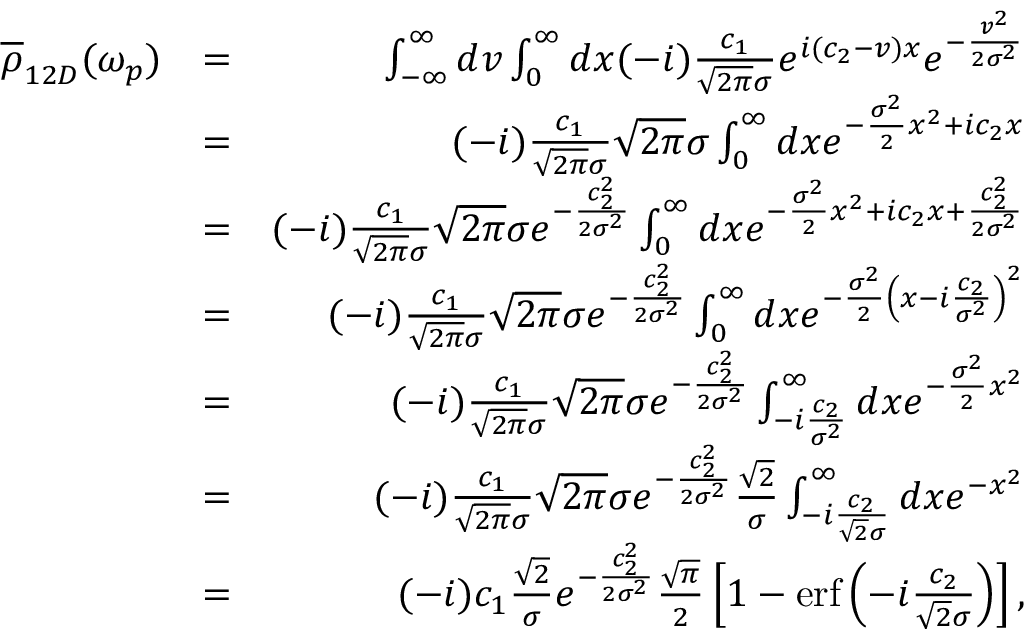Convert formula to latex. <formula><loc_0><loc_0><loc_500><loc_500>\begin{array} { r l r } { \overline { \rho } _ { 1 2 D } ( \omega _ { p } ) } & { = } & { \int _ { - \infty } ^ { \infty } d v \int _ { 0 } ^ { \infty } d x ( - i ) \frac { c _ { 1 } } { \sqrt { 2 \pi } \sigma } e ^ { i ( c _ { 2 } - v ) x } e ^ { - \frac { v ^ { 2 } } { 2 \sigma ^ { 2 } } } } \\ & { = } & { ( - i ) \frac { c _ { 1 } } { \sqrt { 2 \pi } \sigma } \sqrt { 2 \pi } \sigma \int _ { 0 } ^ { \infty } d x e ^ { - \frac { \sigma ^ { 2 } } { 2 } x ^ { 2 } + i c _ { 2 } x } } \\ & { = } & { ( - i ) \frac { c _ { 1 } } { \sqrt { 2 \pi } \sigma } \sqrt { 2 \pi } \sigma e ^ { - \frac { c _ { 2 } ^ { 2 } } { 2 \sigma ^ { 2 } } } \int _ { 0 } ^ { \infty } d x e ^ { - \frac { \sigma ^ { 2 } } { 2 } x ^ { 2 } + i c _ { 2 } x + \frac { c _ { 2 } ^ { 2 } } { 2 \sigma ^ { 2 } } } } \\ & { = } & { ( - i ) \frac { c _ { 1 } } { \sqrt { 2 \pi } \sigma } \sqrt { 2 \pi } \sigma e ^ { - \frac { c _ { 2 } ^ { 2 } } { 2 \sigma ^ { 2 } } } \int _ { 0 } ^ { \infty } d x e ^ { - \frac { \sigma ^ { 2 } } { 2 } \left ( x - i \frac { c _ { 2 } } { \sigma ^ { 2 } } \right ) ^ { 2 } } } \\ & { = } & { ( - i ) \frac { c _ { 1 } } { \sqrt { 2 \pi } \sigma } \sqrt { 2 \pi } \sigma e ^ { - \frac { c _ { 2 } ^ { 2 } } { 2 \sigma ^ { 2 } } } \int _ { - i \frac { c _ { 2 } } { \sigma ^ { 2 } } } ^ { \infty } d x e ^ { - \frac { \sigma ^ { 2 } } { 2 } x ^ { 2 } } } \\ & { = } & { ( - i ) \frac { c _ { 1 } } { \sqrt { 2 \pi } \sigma } \sqrt { 2 \pi } \sigma e ^ { - \frac { c _ { 2 } ^ { 2 } } { 2 \sigma ^ { 2 } } } \frac { \sqrt { 2 } } { \sigma } \int _ { - i \frac { c _ { 2 } } { \sqrt { 2 } \sigma } } ^ { \infty } d x e ^ { - x ^ { 2 } } } \\ & { = } & { ( - i ) c _ { 1 } \frac { \sqrt { 2 } } { \sigma } e ^ { - \frac { c _ { 2 } ^ { 2 } } { 2 \sigma ^ { 2 } } } \frac { \sqrt { \pi } } { 2 } \left [ 1 - e r f \left ( - i \frac { c _ { 2 } } { \sqrt { 2 } \sigma } \right ) \right ] , } \end{array}</formula> 